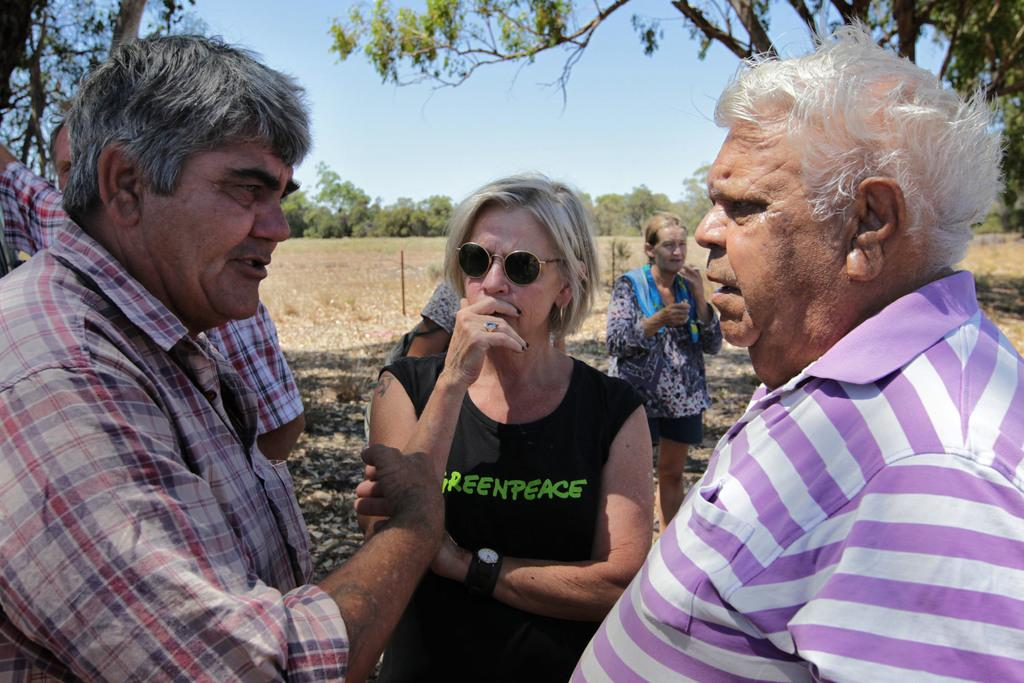What are the people in the image doing? The group of people is standing on the ground in the image. What objects can be seen in the image besides the people? There are poles visible in the image. What type of vegetation is present in the image? There is grass and a group of trees in the image. What is the condition of the sky in the image? The sky is visible in the image, and it appears to be cloudy. What direction is the airplane flying in the image? There is no airplane present in the image. How many women are visible in the image? The provided facts do not mention the gender of the people in the image, so it is impossible to determine the number of women. 